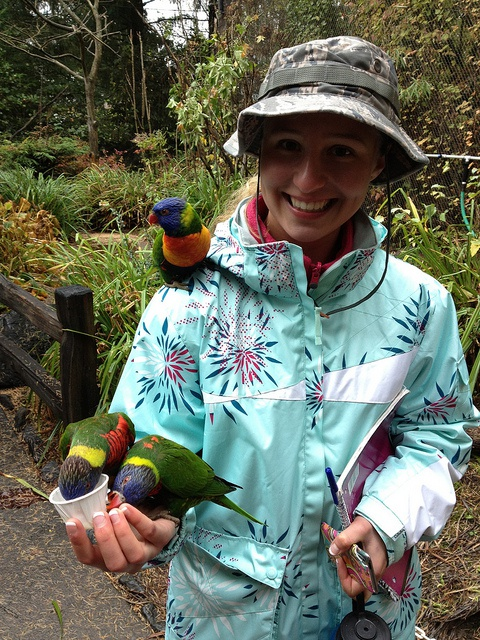Describe the objects in this image and their specific colors. I can see people in black, lightblue, white, and teal tones, bird in black, darkgreen, and gray tones, book in black, maroon, gray, and white tones, bird in black, darkgreen, maroon, and gray tones, and bird in black, maroon, olive, and navy tones in this image. 